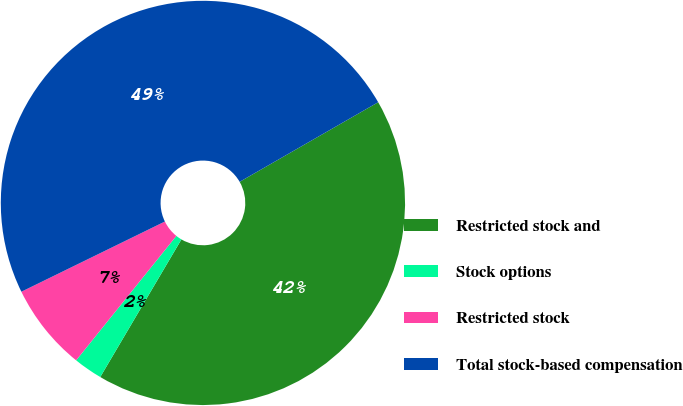<chart> <loc_0><loc_0><loc_500><loc_500><pie_chart><fcel>Restricted stock and<fcel>Stock options<fcel>Restricted stock<fcel>Total stock-based compensation<nl><fcel>41.78%<fcel>2.31%<fcel>6.97%<fcel>48.94%<nl></chart> 